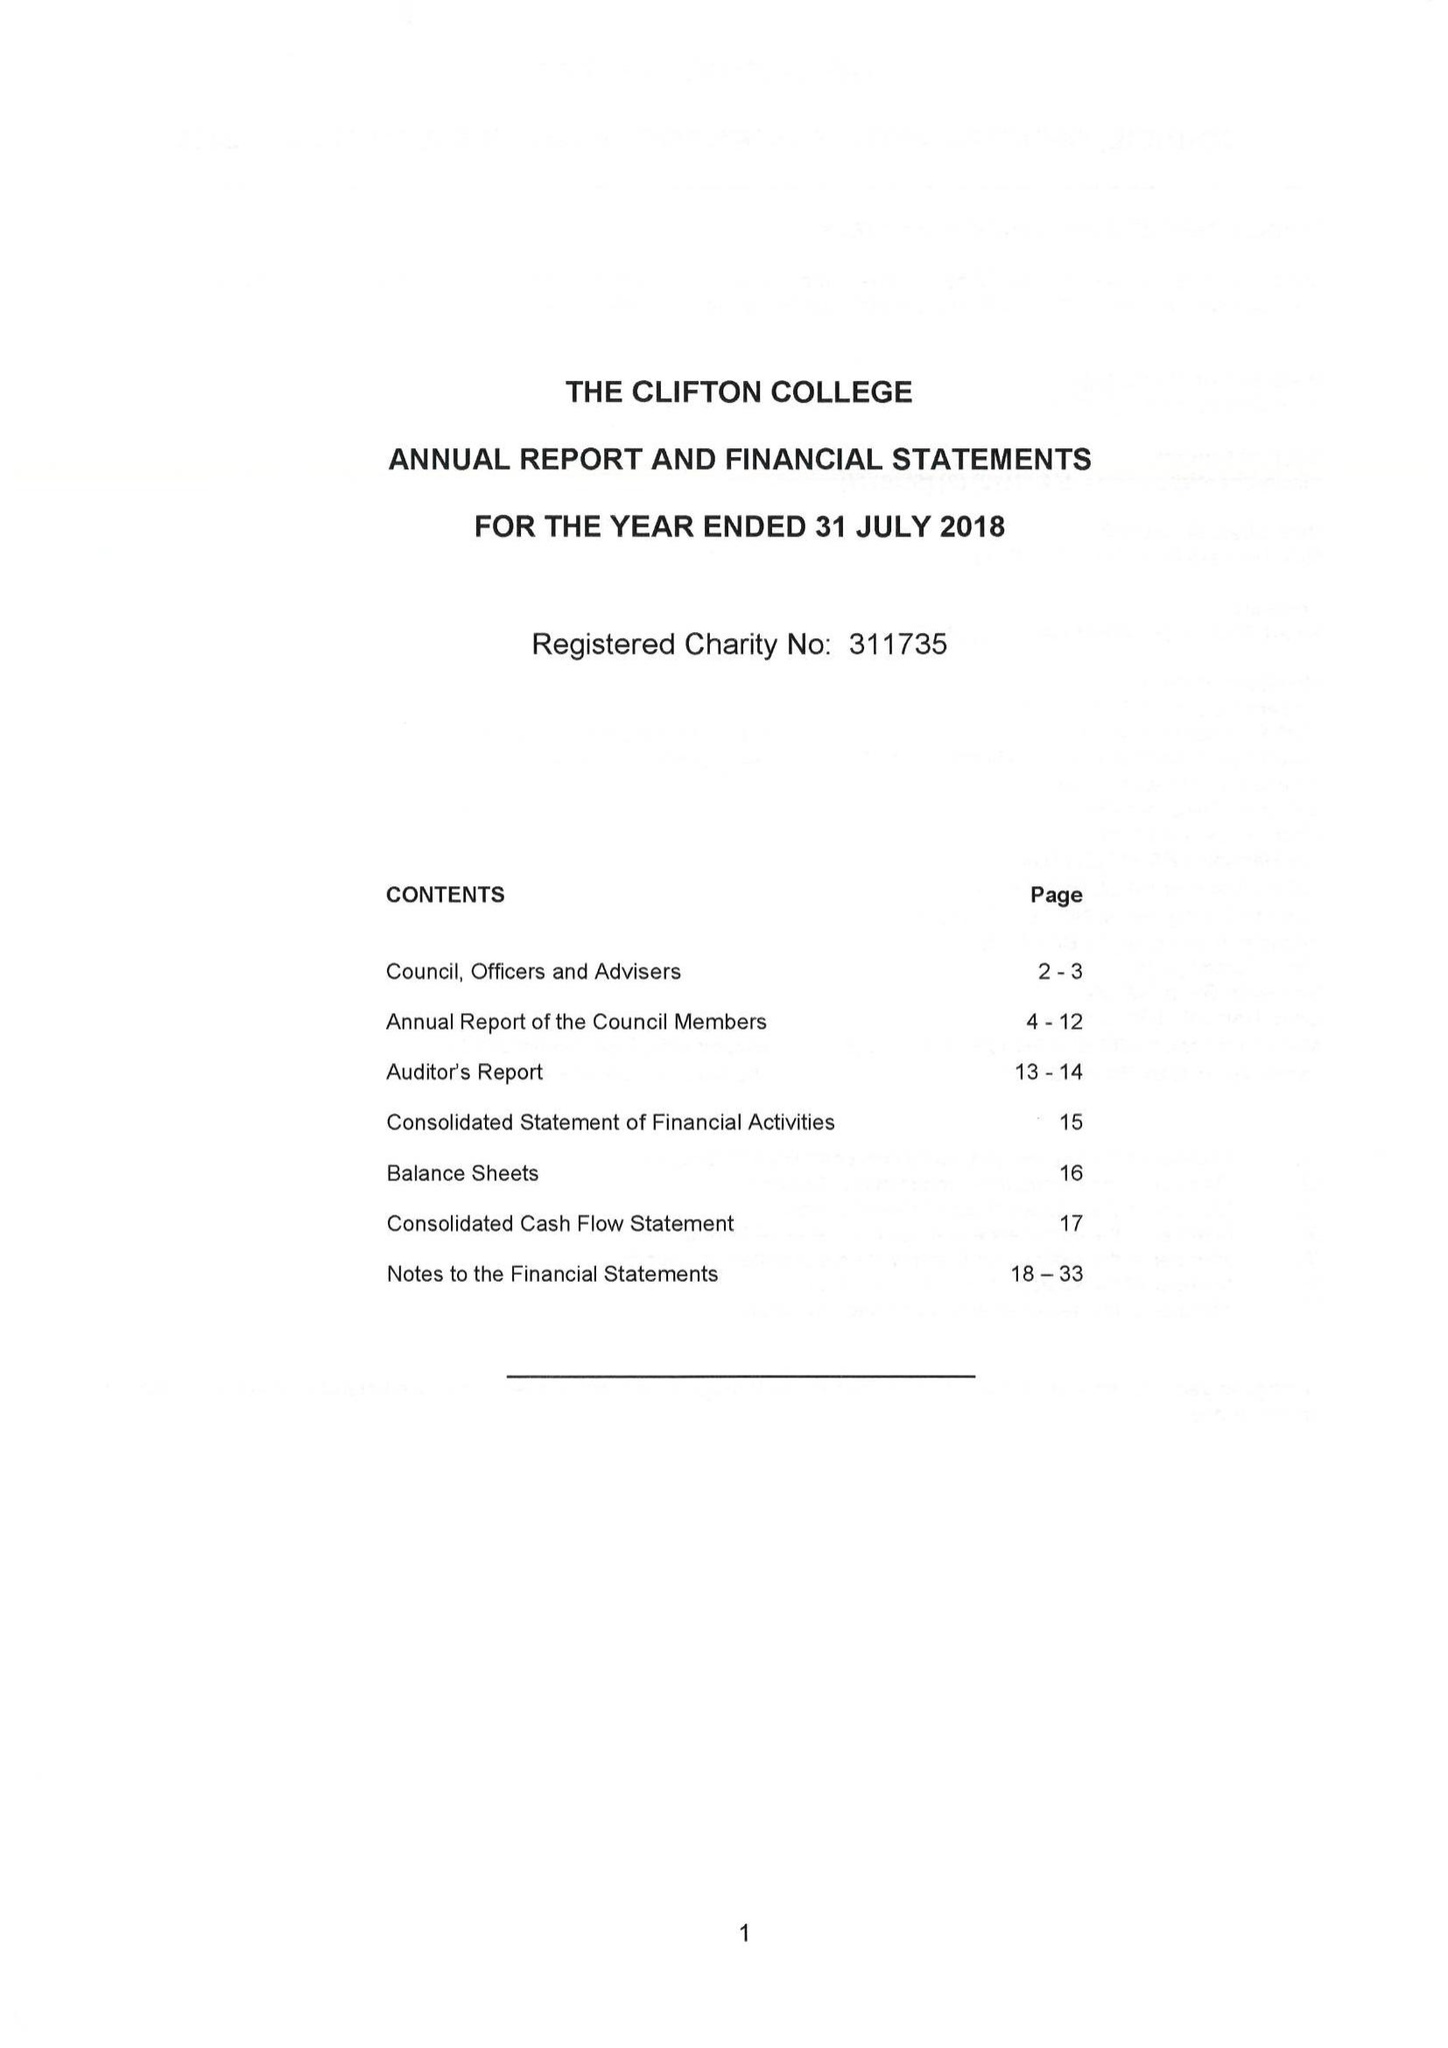What is the value for the income_annually_in_british_pounds?
Answer the question using a single word or phrase. 29105738.00 